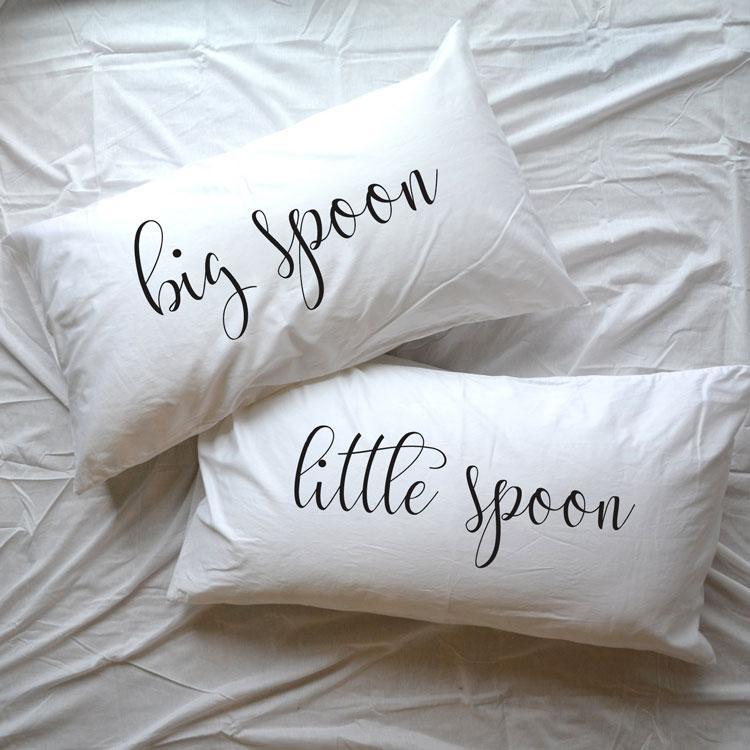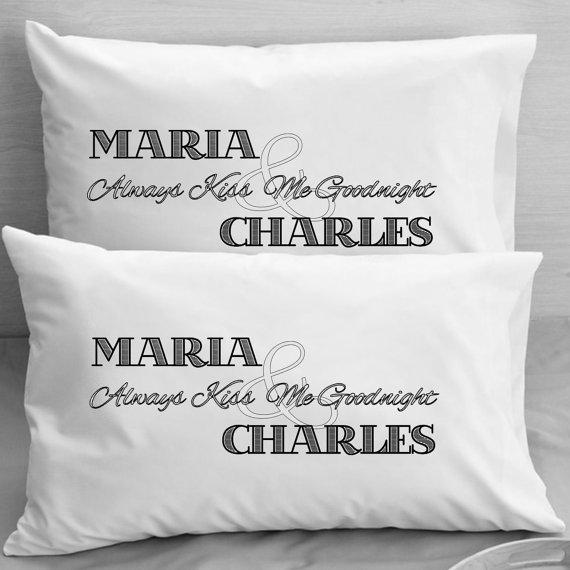The first image is the image on the left, the second image is the image on the right. For the images displayed, is the sentence "A pair of pillows are side-by-side on a bed and printed with spoon shapes below lettering." factually correct? Answer yes or no. No. The first image is the image on the left, the second image is the image on the right. Analyze the images presented: Is the assertion "Each image shows a set of white pillows angled upward at the head of a bed, each set with the same saying but a different letter design." valid? Answer yes or no. No. 